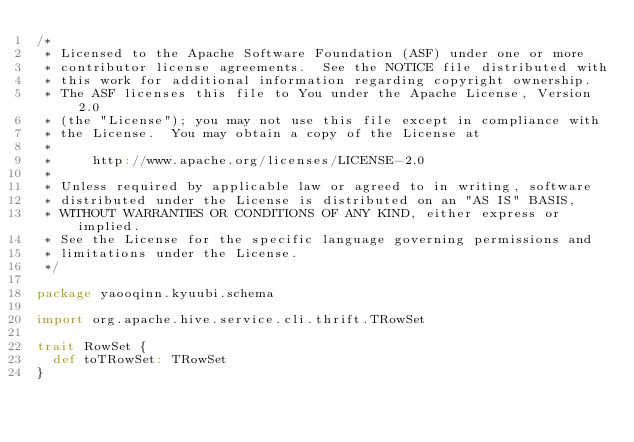<code> <loc_0><loc_0><loc_500><loc_500><_Scala_>/*
 * Licensed to the Apache Software Foundation (ASF) under one or more
 * contributor license agreements.  See the NOTICE file distributed with
 * this work for additional information regarding copyright ownership.
 * The ASF licenses this file to You under the Apache License, Version 2.0
 * (the "License"); you may not use this file except in compliance with
 * the License.  You may obtain a copy of the License at
 *
 *     http://www.apache.org/licenses/LICENSE-2.0
 *
 * Unless required by applicable law or agreed to in writing, software
 * distributed under the License is distributed on an "AS IS" BASIS,
 * WITHOUT WARRANTIES OR CONDITIONS OF ANY KIND, either express or implied.
 * See the License for the specific language governing permissions and
 * limitations under the License.
 */

package yaooqinn.kyuubi.schema

import org.apache.hive.service.cli.thrift.TRowSet

trait RowSet {
  def toTRowSet: TRowSet
}
</code> 